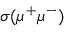<formula> <loc_0><loc_0><loc_500><loc_500>\sigma ( \mu ^ { + } \mu ^ { - } )</formula> 